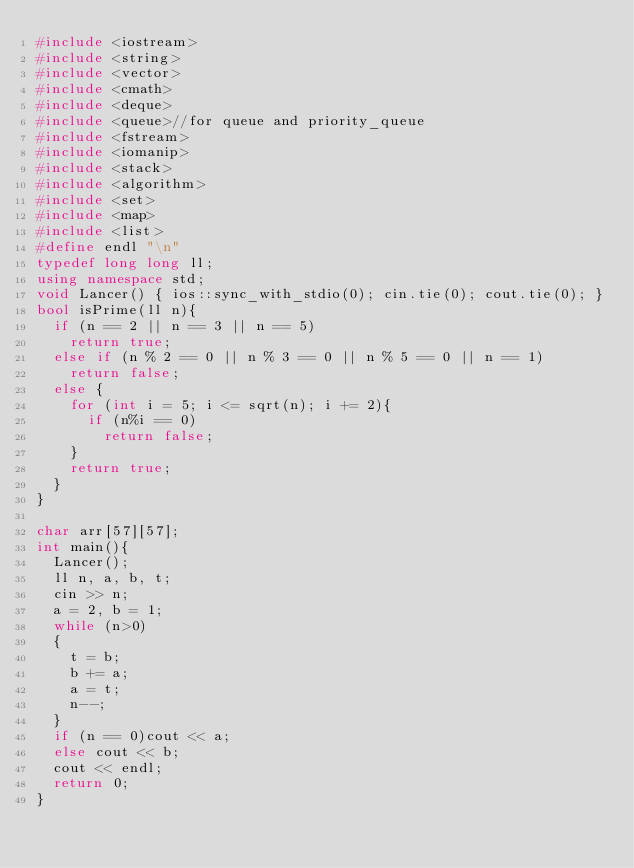<code> <loc_0><loc_0><loc_500><loc_500><_C++_>#include <iostream>
#include <string>
#include <vector>
#include <cmath>
#include <deque>
#include <queue>//for queue and priority_queue
#include <fstream>
#include <iomanip>
#include <stack>
#include <algorithm>
#include <set>
#include <map>
#include <list>
#define endl "\n"
typedef long long ll;
using namespace std;
void Lancer() { ios::sync_with_stdio(0); cin.tie(0); cout.tie(0); }
bool isPrime(ll n){
	if (n == 2 || n == 3 || n == 5)
		return true;
	else if (n % 2 == 0 || n % 3 == 0 || n % 5 == 0 || n == 1)
		return false;
	else {
		for (int i = 5; i <= sqrt(n); i += 2){
			if (n%i == 0)
				return false;
		}
		return true;
	}
}

char arr[57][57];
int main(){
	Lancer();
	ll n, a, b, t;
	cin >> n;
	a = 2, b = 1;
	while (n>0)
	{
		t = b;
		b += a;
		a = t;
		n--;
	}
	if (n == 0)cout << a;
	else cout << b;
	cout << endl;
	return 0;
}
</code> 